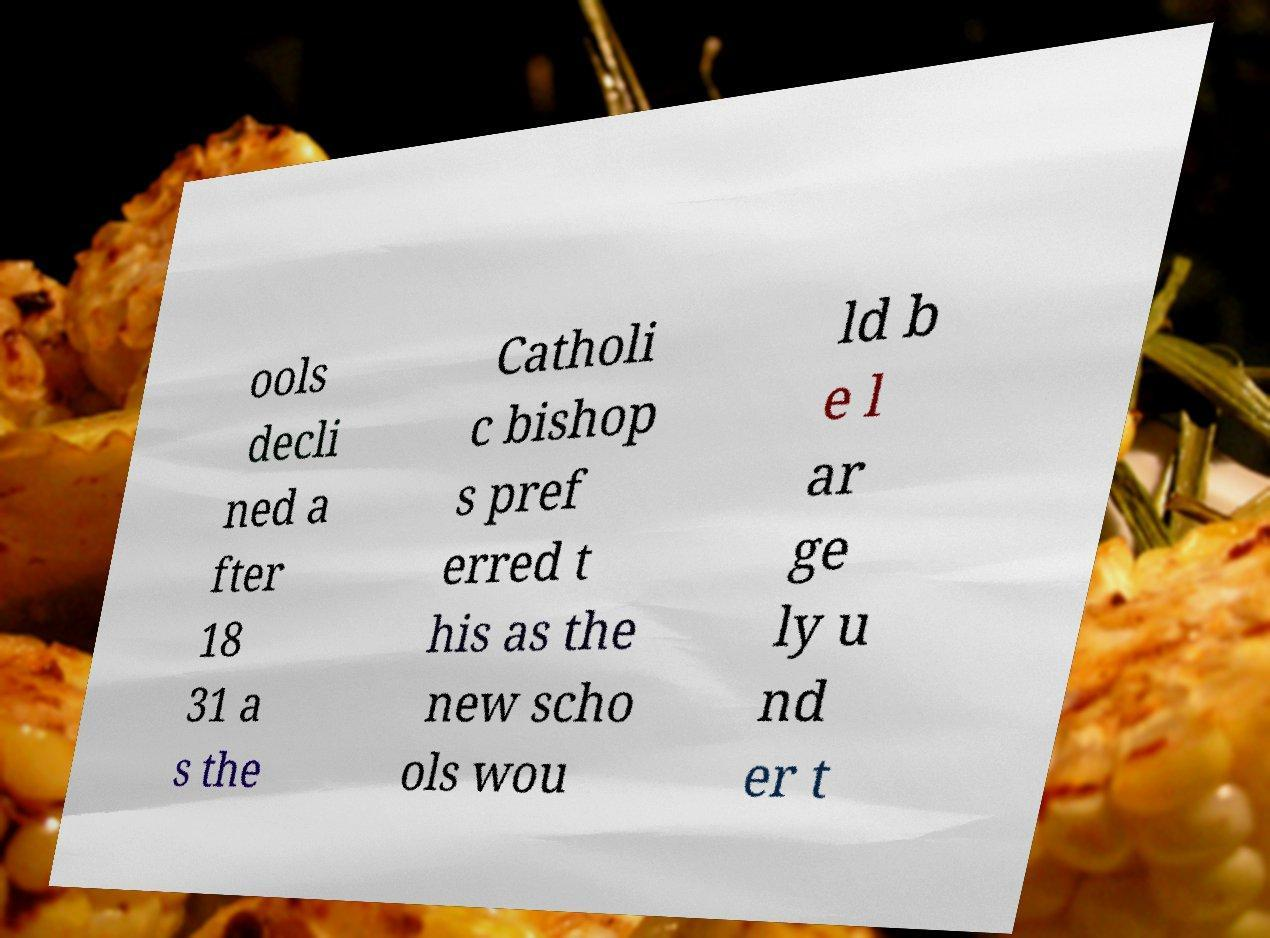Please read and relay the text visible in this image. What does it say? ools decli ned a fter 18 31 a s the Catholi c bishop s pref erred t his as the new scho ols wou ld b e l ar ge ly u nd er t 